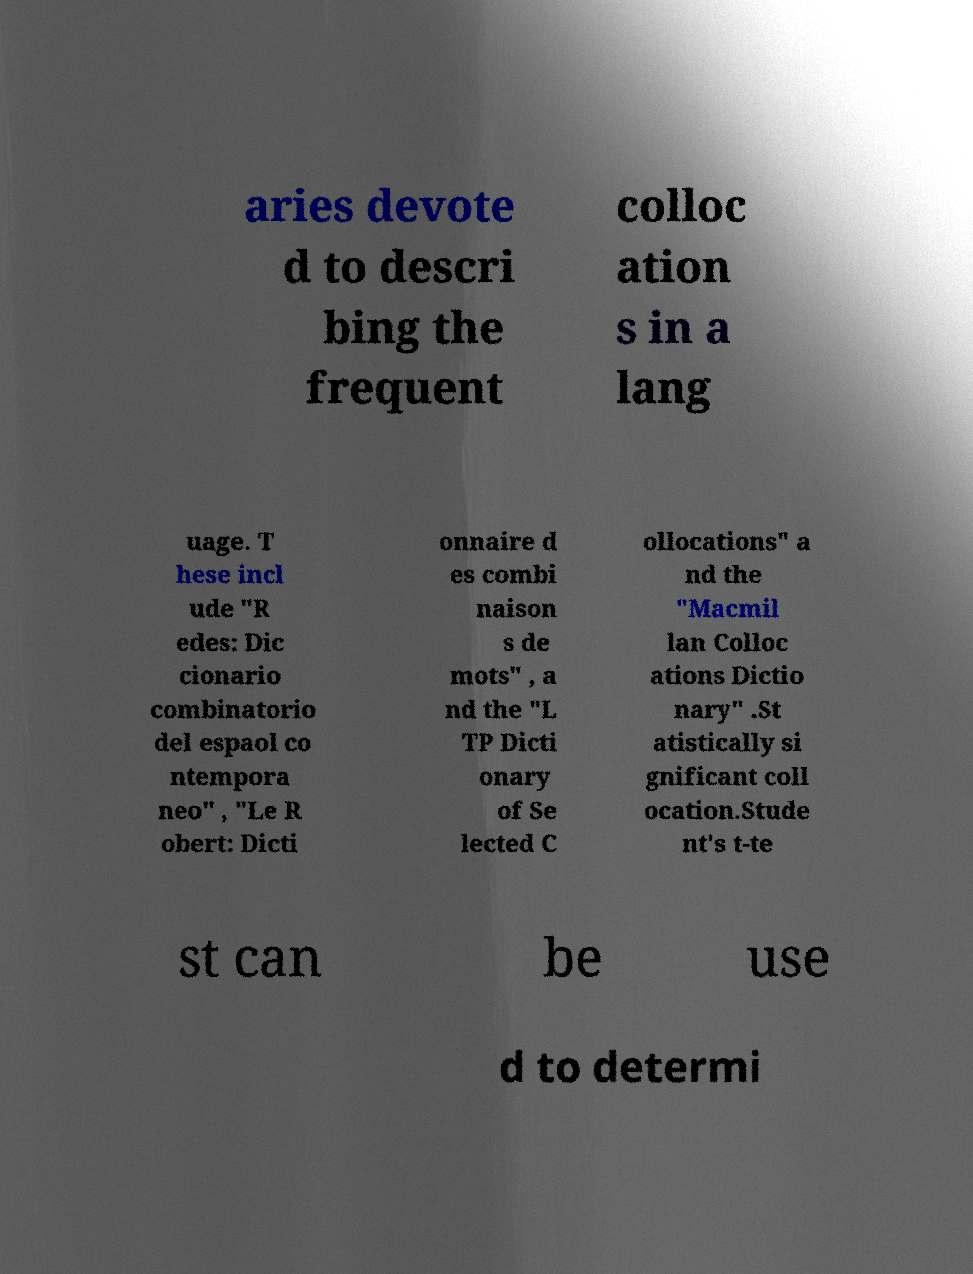There's text embedded in this image that I need extracted. Can you transcribe it verbatim? aries devote d to descri bing the frequent colloc ation s in a lang uage. T hese incl ude "R edes: Dic cionario combinatorio del espaol co ntempora neo" , "Le R obert: Dicti onnaire d es combi naison s de mots" , a nd the "L TP Dicti onary of Se lected C ollocations" a nd the "Macmil lan Colloc ations Dictio nary" .St atistically si gnificant coll ocation.Stude nt's t-te st can be use d to determi 